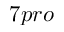<formula> <loc_0><loc_0><loc_500><loc_500>7 p r o</formula> 